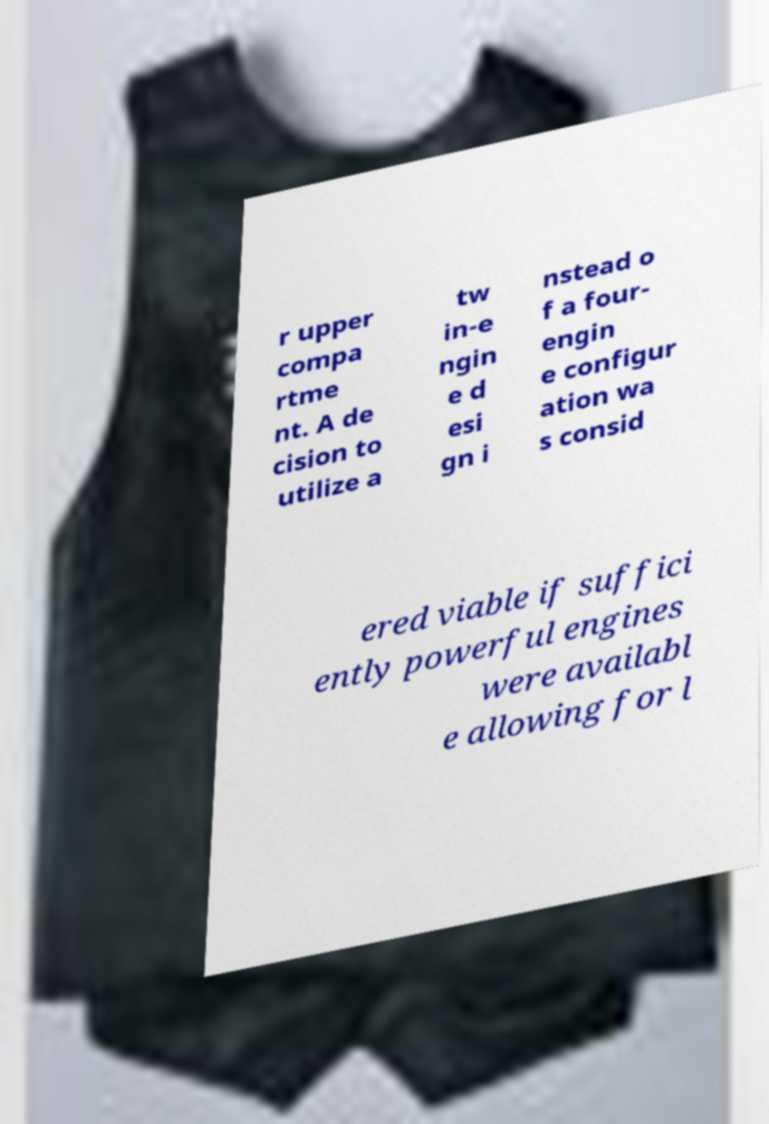Could you extract and type out the text from this image? r upper compa rtme nt. A de cision to utilize a tw in-e ngin e d esi gn i nstead o f a four- engin e configur ation wa s consid ered viable if suffici ently powerful engines were availabl e allowing for l 